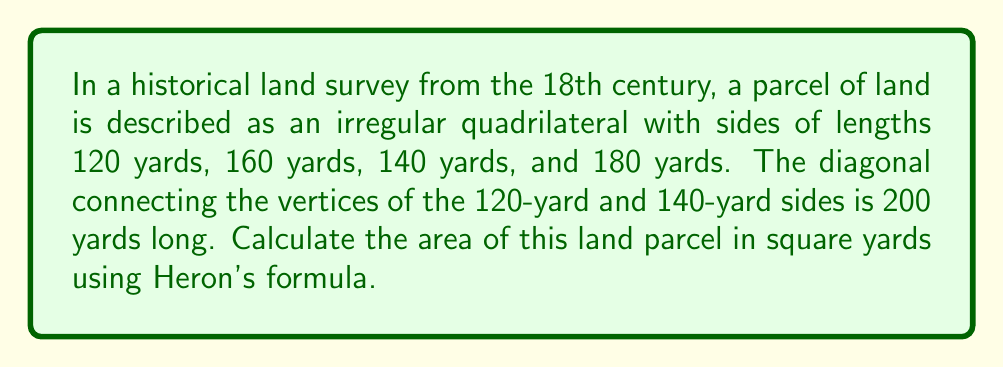Solve this math problem. To solve this problem, we'll use the following steps:

1) First, we need to recognize that this quadrilateral can be divided into two triangles by the given diagonal.

2) We'll calculate the area of each triangle using Heron's formula and then add them together.

3) Heron's formula states that the area of a triangle with sides $a$, $b$, and $c$ is:

   $$A = \sqrt{s(s-a)(s-b)(s-c)}$$

   where $s$ is the semi-perimeter: $s = \frac{a+b+c}{2}$

4) For the first triangle:
   $a = 120$, $b = 160$, $c = 200$
   
   $s = \frac{120 + 160 + 200}{2} = 240$

   $A_1 = \sqrt{240(240-120)(240-160)(240-200)}$
   
   $A_1 = \sqrt{240 \cdot 120 \cdot 80 \cdot 40} = \sqrt{92,160,000} = 9600$

5) For the second triangle:
   $a = 140$, $b = 180$, $c = 200$
   
   $s = \frac{140 + 180 + 200}{2} = 260$

   $A_2 = \sqrt{260(260-140)(260-180)(260-200)}$
   
   $A_2 = \sqrt{260 \cdot 120 \cdot 80 \cdot 60} = \sqrt{149,760,000} = 12,240$

6) The total area is the sum of these two triangles:

   $A_{total} = A_1 + A_2 = 9600 + 12,240 = 21,840$

Therefore, the area of the land parcel is 21,840 square yards.
Answer: 21,840 square yards 